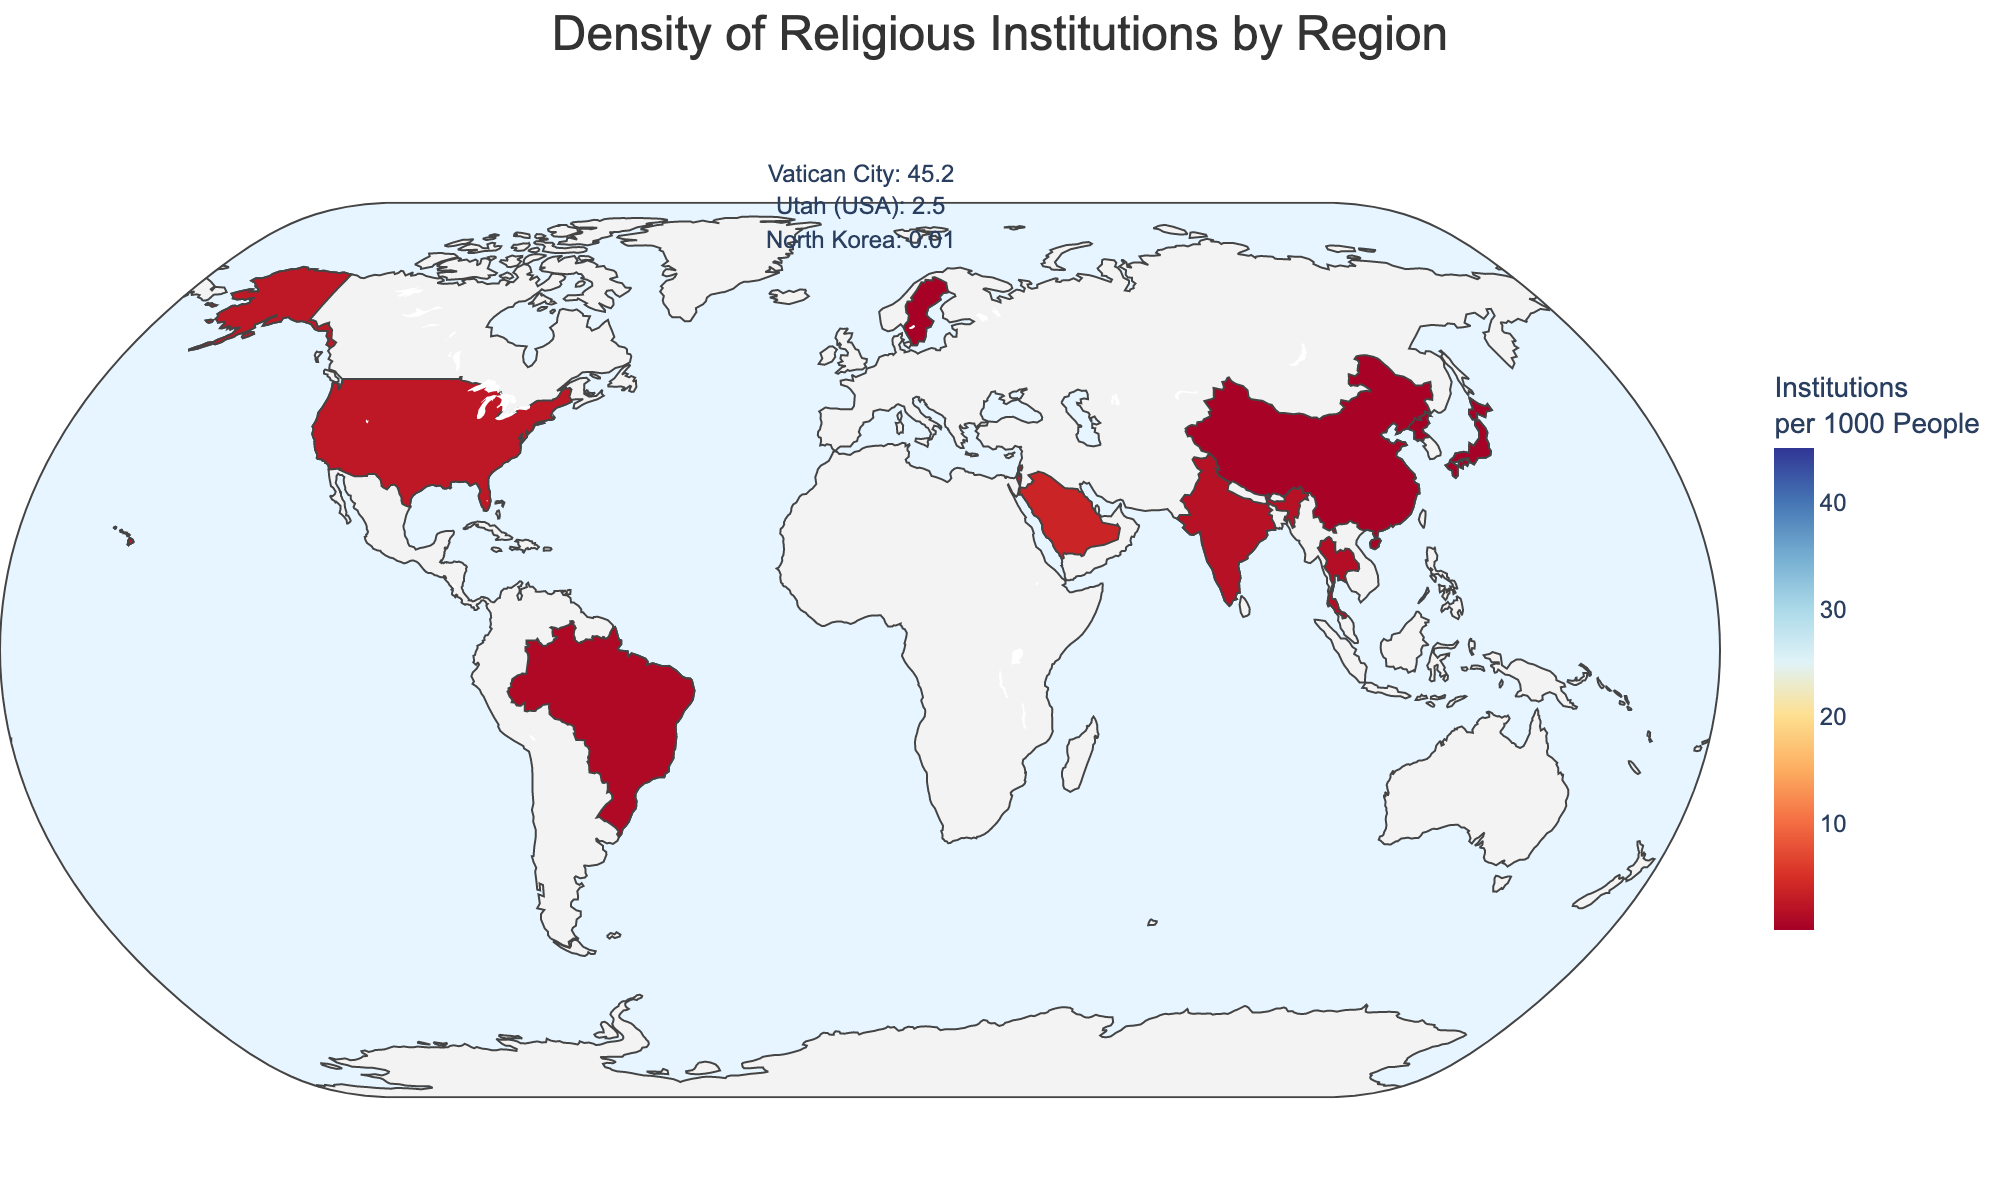What is the title of the figure? The title of the figure is generally displayed at the top of plots and contains a brief description of the content. In this case, the title is shown as "Density of Religious Institutions by Region".
Answer: Density of Religious Institutions by Region Which region has the highest density of religious institutions per 1000 people? From the figure, the highest value of "Religious Institutions per 1000 People" can be seen in the data point for Vatican City, as it has a noticeably higher density compared to other regions.
Answer: Vatican City Compare the density of religious institutions in Israel and India. Which has a higher density? The figure shows the value for "Religious Institutions per 1000 People" on the color scale. By comparing the densities given for Israel (2.9) and India (1.8), Israel has the higher density.
Answer: Israel How does the density in North Korea compare to that in Japan? The value for "Religious Institutions per 1000 People" for North Korea is 0.01, and for Japan it is 0.1. Comparing these, Japan has a higher density of religious institutions per 1000 people than North Korea.
Answer: Japan What is the dominant religion in Thailand as shown in the figure? The hover data provides additional information, including the dominant religion for each region. Thailand is listed with Buddhism as its dominant religion.
Answer: Buddhism What is the total number of regions shown in the plot? By counting the individual entries in the dataset, we can sum the total number of regions represented in the plot. The dataset lists 12 different regions.
Answer: 12 What can be inferred about regions with a low density of religious institutions? Regions like China, Sweden, Japan, and North Korea exhibit low densities of religious institutions per 1000 people, as indicated by their placement on the lower end of the color scale (darker colors).
Answer: Low or non-religious trends Which regions have Catholicism as the dominant religion, and how do their densities compare? By identifying the regions with Catholicism as the dominant religion (Vatican City and Brazil) and comparing their values, we see Vatican City has a much higher density (45.2) than Brazil (1.0).
Answer: Vatican City has higher density Is the region with the lowest density of religious institutions atheist? Looking at the figure, North Korea has the lowest density (0.01) and its dominant religion is listed as State Atheism, which often involves suppression of religious activities.
Answer: Yes 